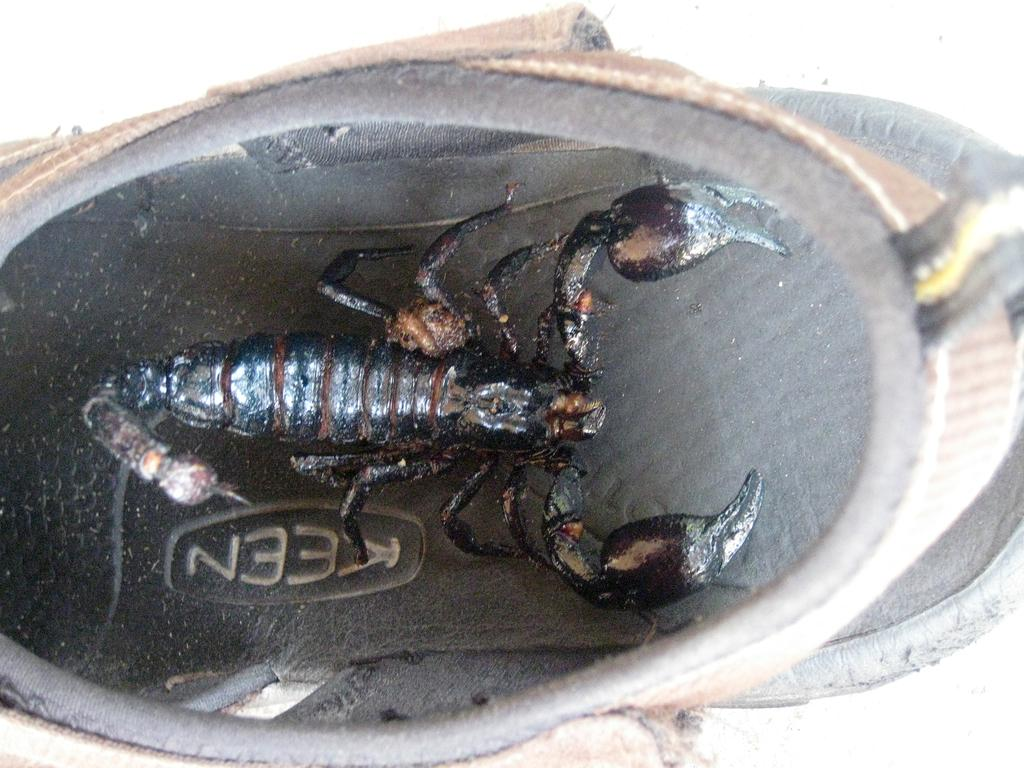Provide a one-sentence caption for the provided image. A scorpion is inside a Keen brand shoe. 